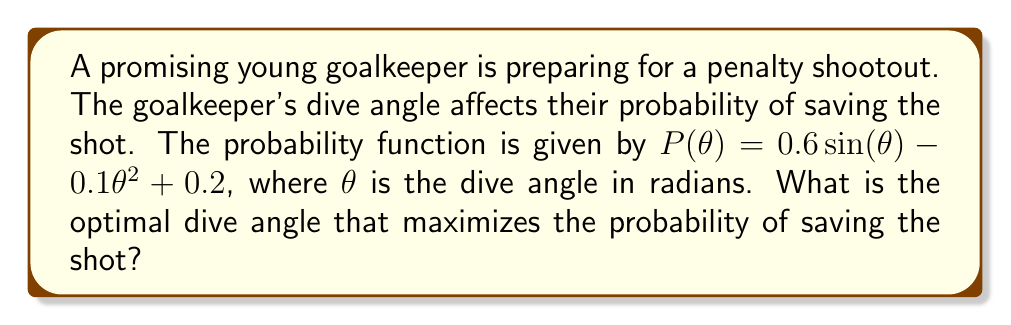Give your solution to this math problem. To find the optimal dive angle, we need to maximize the probability function $P(\theta)$. This is a nonlinear optimization problem that can be solved using calculus.

Step 1: Find the derivative of $P(\theta)$ with respect to $\theta$.
$$\frac{dP}{d\theta} = 0.6 \cos(\theta) - 0.2\theta$$

Step 2: Set the derivative equal to zero to find the critical points.
$$0.6 \cos(\theta) - 0.2\theta = 0$$

Step 3: Solve the equation for $\theta$. This is a nonlinear equation that cannot be solved algebraically. We can use numerical methods like Newton's method to approximate the solution.

Using Newton's method with an initial guess of $\theta_0 = 1$, we iterate:

$$\theta_{n+1} = \theta_n - \frac{0.6 \cos(\theta_n) - 0.2\theta_n}{-0.6 \sin(\theta_n) - 0.2}$$

After a few iterations, we converge to $\theta \approx 1.1653$ radians.

Step 4: Verify that this is a maximum by checking the second derivative:
$$\frac{d^2P}{d\theta^2} = -0.6 \sin(\theta) - 0.2$$

At $\theta \approx 1.1653$, the second derivative is negative, confirming that this is a local maximum.

Step 5: Convert the angle from radians to degrees:
$$1.1653 \text{ radians} \times \frac{180^\circ}{\pi} \approx 66.76^\circ$$

Therefore, the optimal dive angle is approximately 66.76 degrees.
Answer: 66.76° 